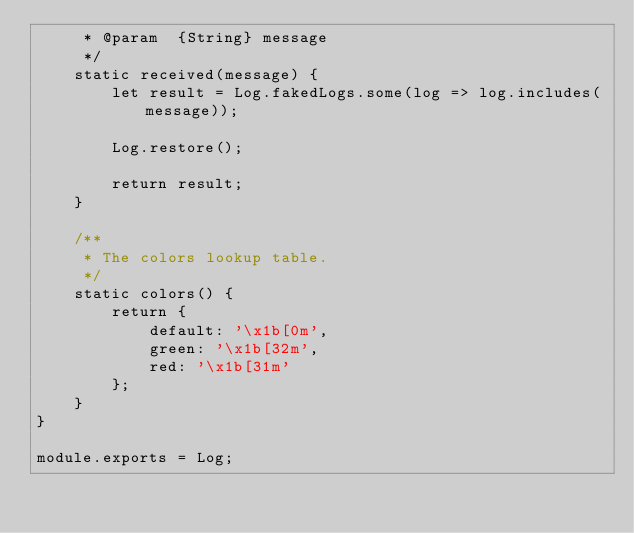<code> <loc_0><loc_0><loc_500><loc_500><_JavaScript_>     * @param  {String} message
     */
    static received(message) {
        let result = Log.fakedLogs.some(log => log.includes(message));

        Log.restore();

        return result;
    }

    /**
     * The colors lookup table.
     */
    static colors() {
        return {
            default: '\x1b[0m',
            green: '\x1b[32m',
            red: '\x1b[31m'
        };
    }
}

module.exports = Log;
</code> 